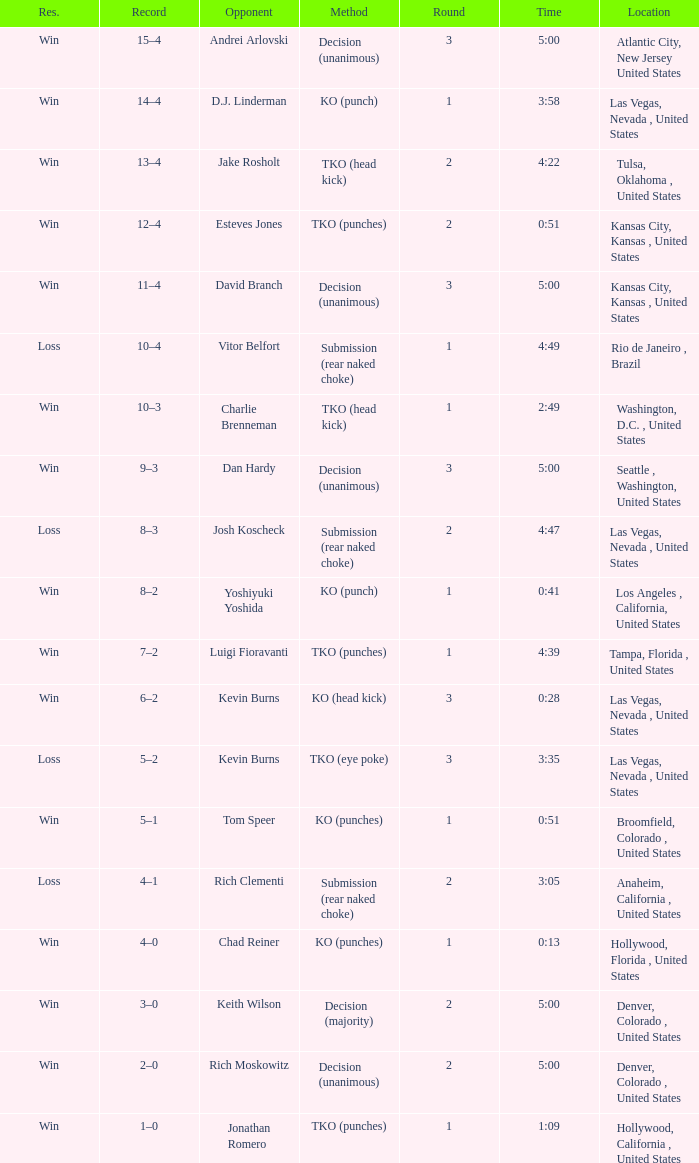Which record has a duration of 13 seconds? 4–0. 